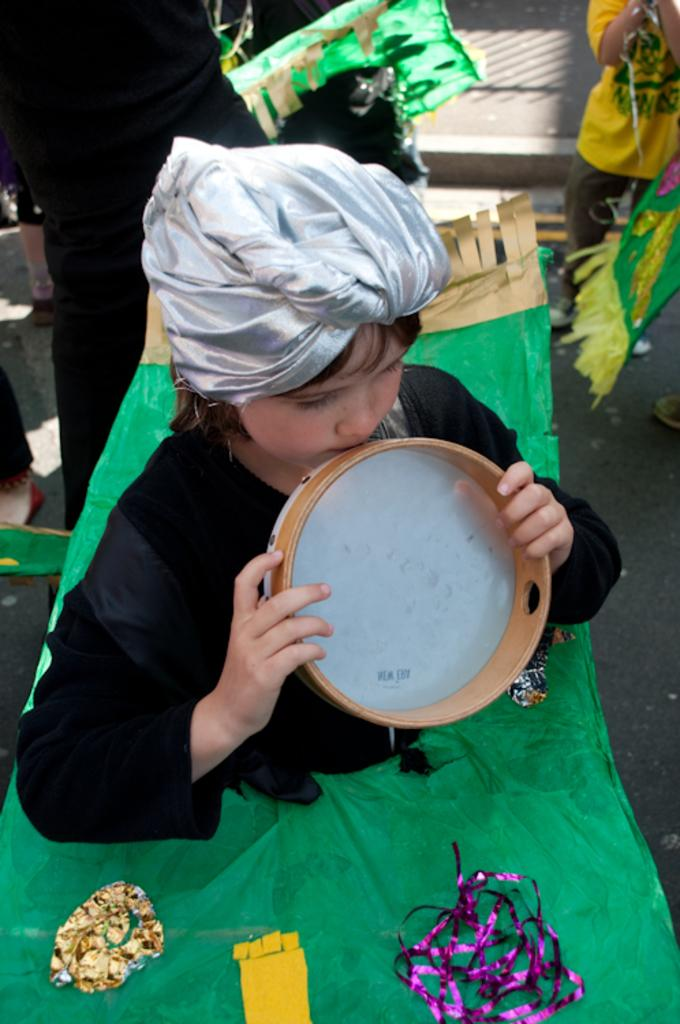What is the person in the image doing? The person is standing in the image and holding a tambourine. What else can be seen in the image besides the person? There are decorative items in the image. Are there any other people in the image? Yes, there is a group of people standing in the image. What type of bed can be seen in the image? There is no bed present in the image. How does the wave affect the group of people in the image? There is no wave present in the image, so it cannot affect the group of people. 